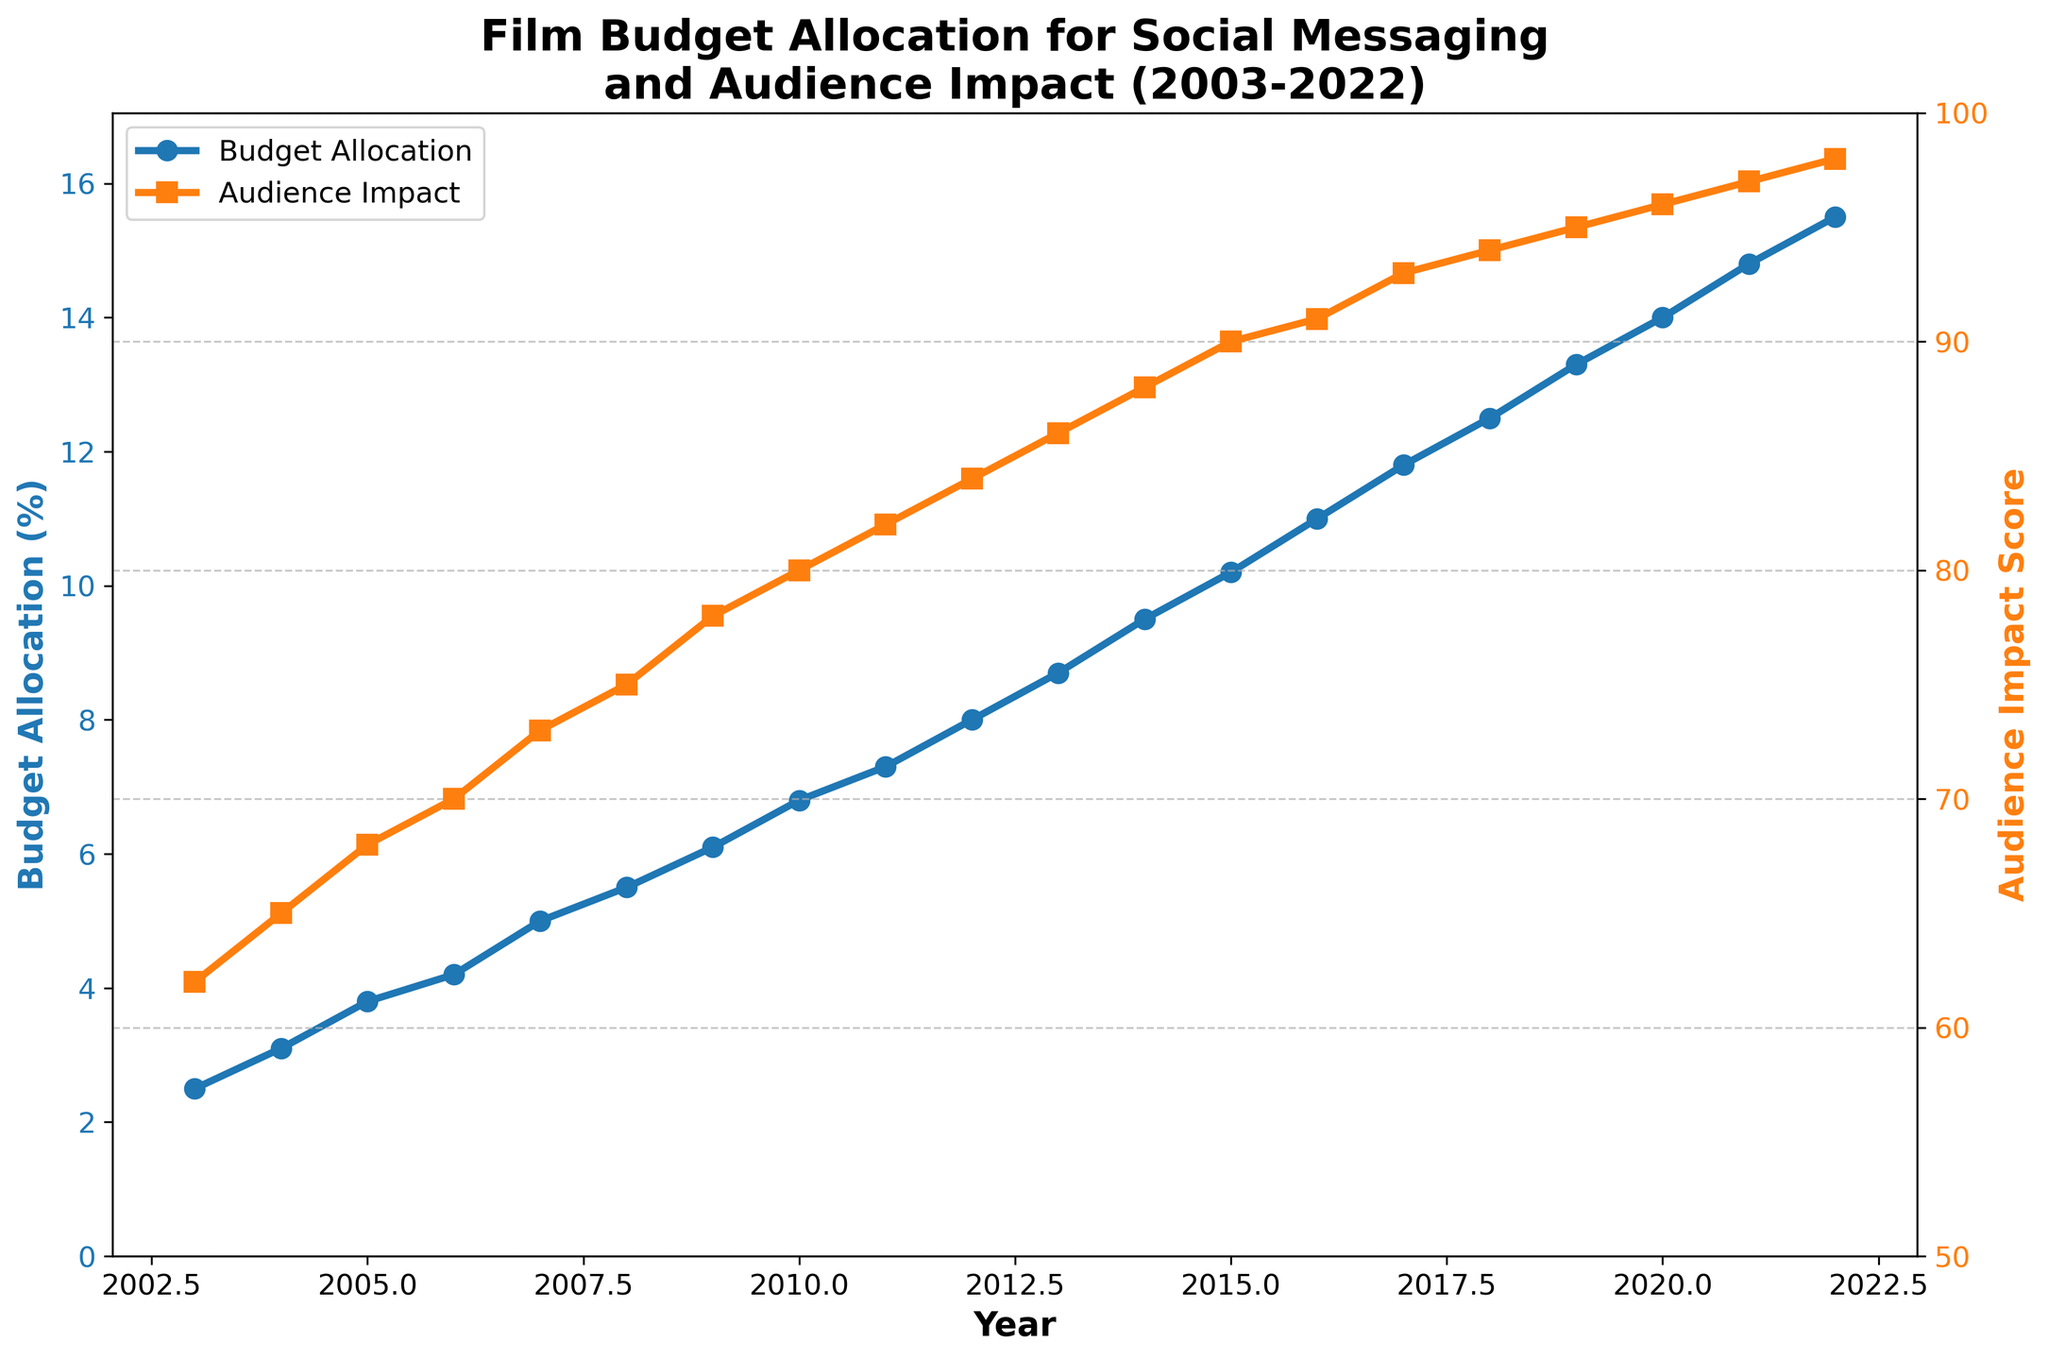What is the general trend in budget allocation for social messaging between 2003 and 2022? The budget allocation for social messaging shows a general upward trend from 2.5% in 2003 to 15.5% in 2022. This indicates a consistent increase in the percentage of budget allocated for social messaging over the two decades.
Answer: Upward trend How did the audience impact score change from 2003 to 2022? The audience impact score increased from 62 in 2003 to 98 in 2022. This shows a steady rise in the score over the years.
Answer: Increased from 62 to 98 In which year did the budget allocation percentage first exceed 10%? By examining the line representing budget allocation, we see that in 2014, the budget allocation percentage first reached 10.2%, thus exceeding 10%.
Answer: 2014 Compare the budget allocation for social messaging in 2010 and 2020. In 2010, the budget allocation was 6.8%, while in 2020, it was 14.0%. This shows that the allocation more than doubled over this 10-year period.
Answer: 6.8% (2010), 14.0% (2020) Between which consecutive years did the audience impact score see the highest increase? By inspecting the data points, the highest year-on-year increase in the audience impact score occurred between 2021 and 2022, where the score increased from 97 to 98.
Answer: 2021-2022 What is the average budget allocation percentage for the first decade (2003-2012)? Summing up the budget allocation percentages from 2003 to 2012 and dividing by the number of years (10): (2.5 + 3.1 + 3.8 + 4.2 + 5.0 + 5.5 + 6.1 + 6.8 + 7.3 + 8.0) / 10 = 5.2%.
Answer: 5.2% What was the audience impact score in 2007 and how does it compare to 2017? The audience impact score in 2007 was 73, and in 2017, it was 93. This indicates an increase of 20 points over the 10-year period.
Answer: 73 (2007), 93 (2017) How does the visual appearance of the lines for budget allocation and audience impact score differ? The budget allocation line is marked with circles and is colored blue, while the audience impact score line is marked with squares and is colored orange. This visual differentiation helps to distinguish between the two data sets on the same graph.
Answer: Blue circles (budget), Orange squares (impact) Which year witnessed the smallest increase in audience impact score? The smallest increase in audience impact score occurs between 2019 and 2020, where the score increased from 95 to 96, indicating an increase of just 1 point.
Answer: 2019-2020 If we were to draw a best-fit line for the budget allocation over the years, would it be sloped upwards, downwards, or be horizontal? Given the steady increase in budget allocation percentages over the years, a best-fit line would be sloped upwards.
Answer: Upwards 